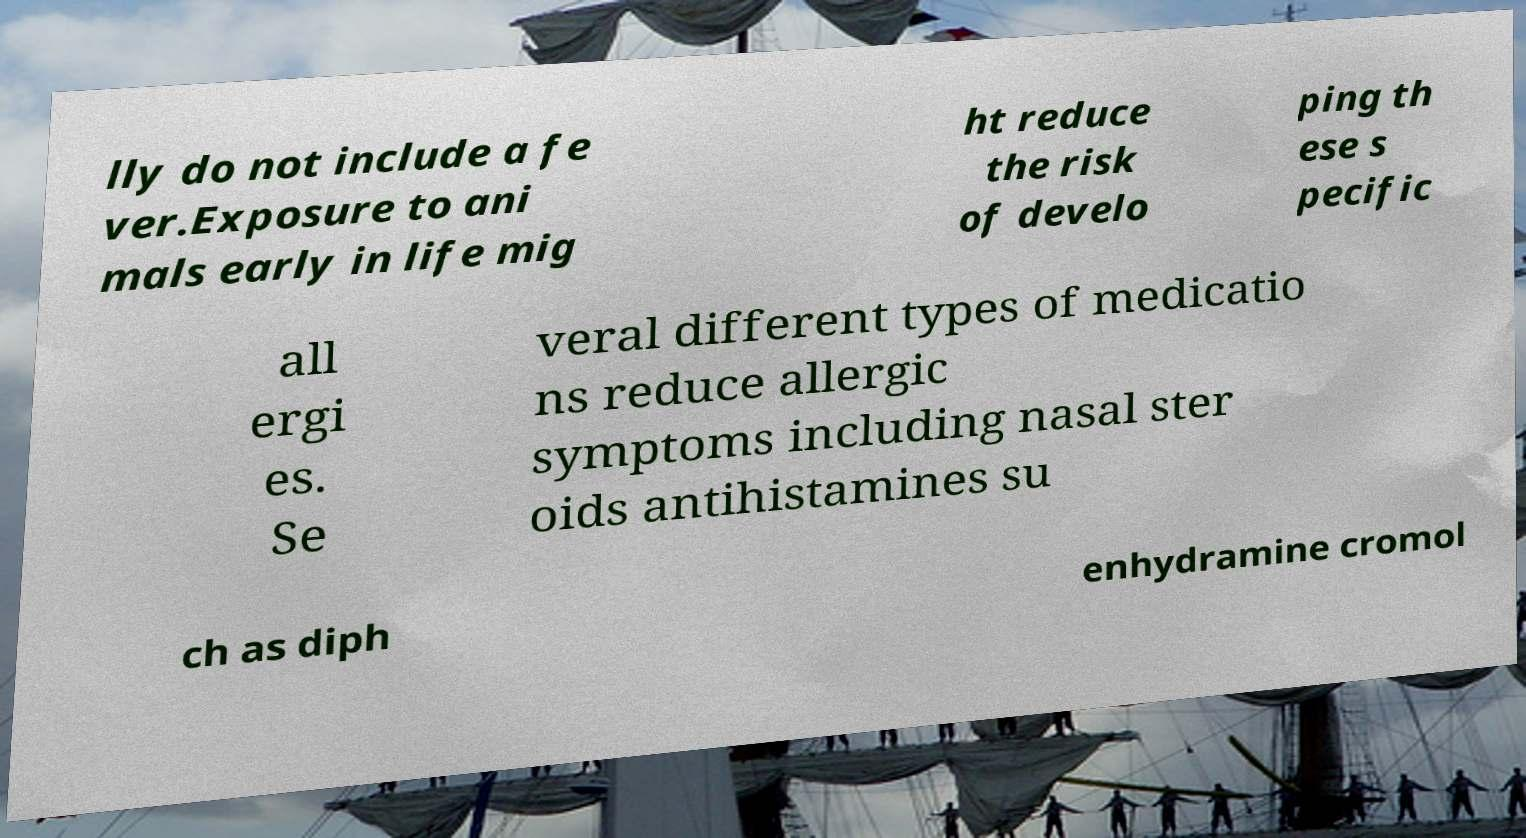I need the written content from this picture converted into text. Can you do that? lly do not include a fe ver.Exposure to ani mals early in life mig ht reduce the risk of develo ping th ese s pecific all ergi es. Se veral different types of medicatio ns reduce allergic symptoms including nasal ster oids antihistamines su ch as diph enhydramine cromol 